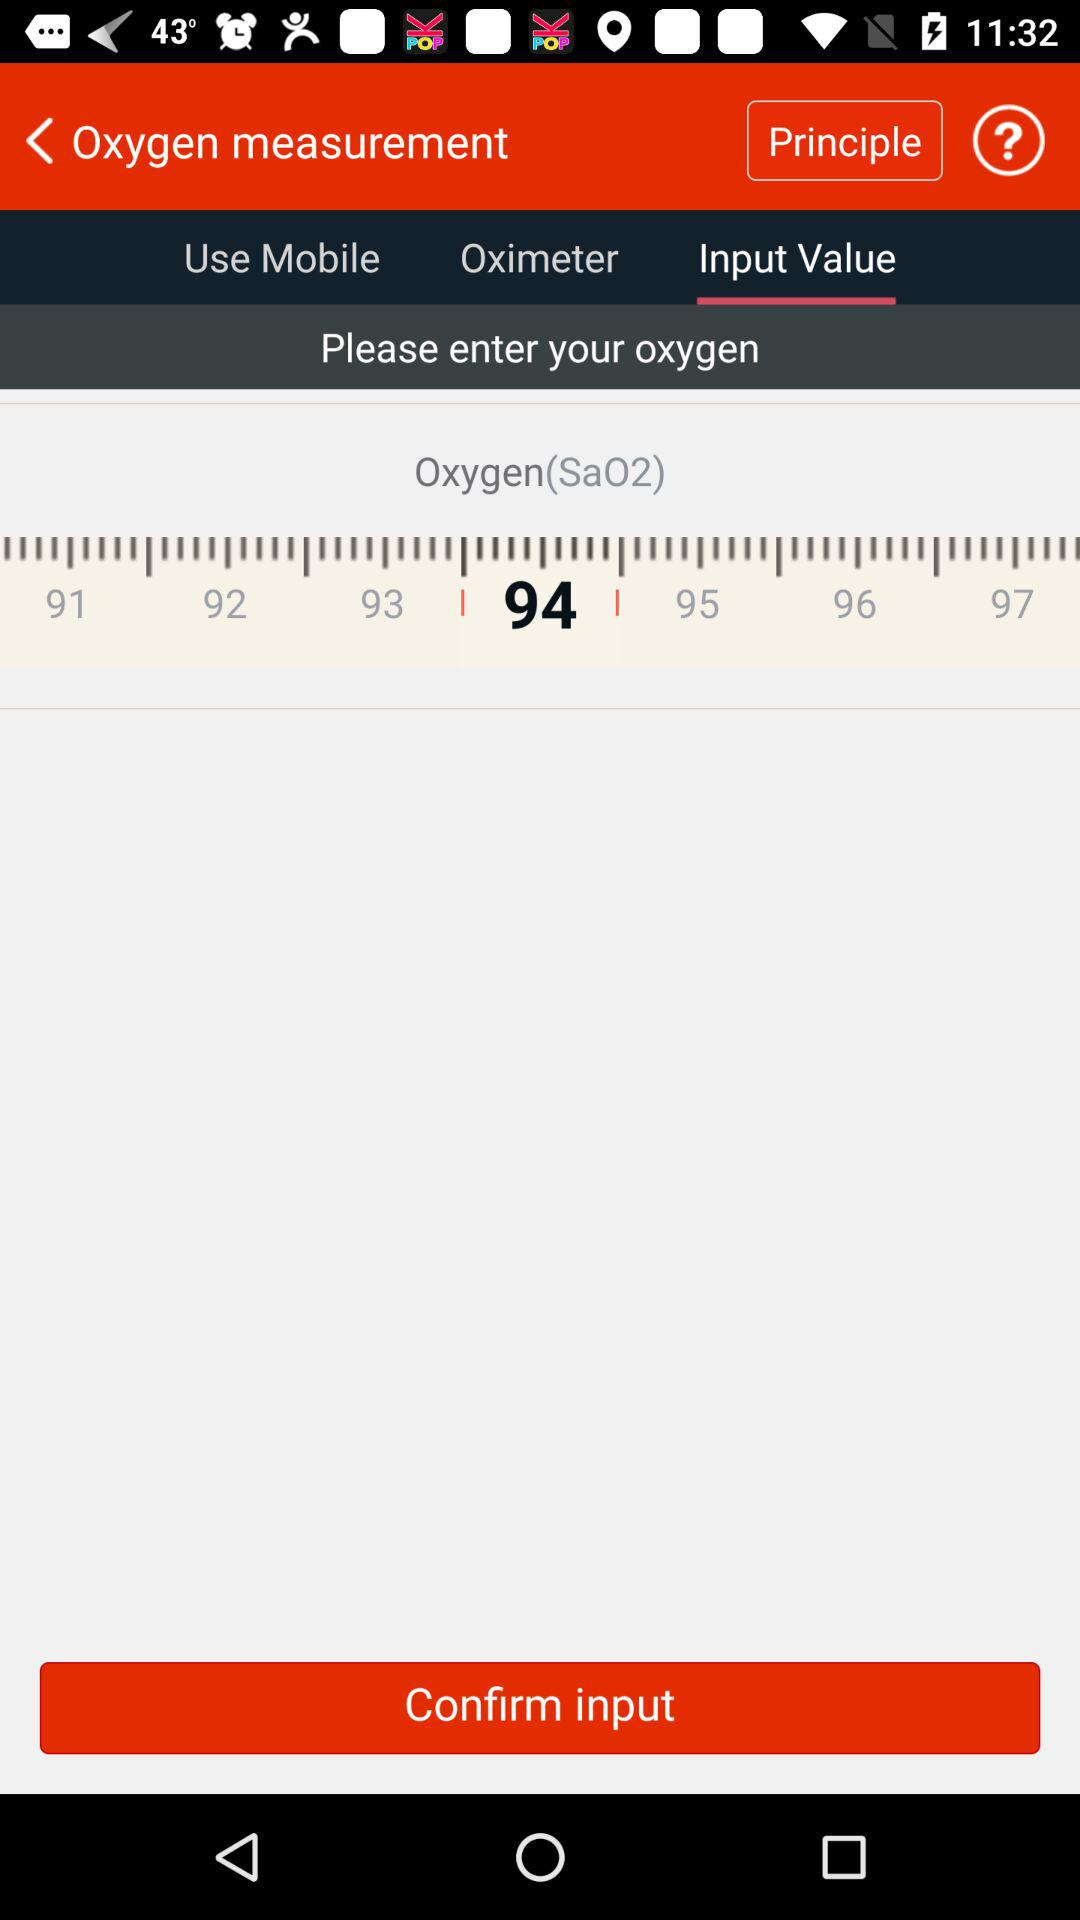Which tab is selected? The selected tab is "Input Value". 